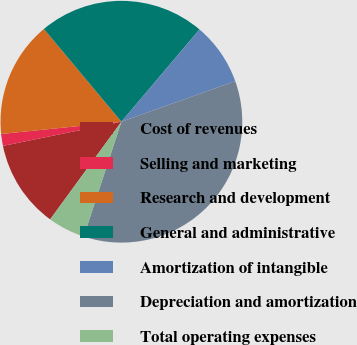Convert chart to OTSL. <chart><loc_0><loc_0><loc_500><loc_500><pie_chart><fcel>Cost of revenues<fcel>Selling and marketing<fcel>Research and development<fcel>General and administrative<fcel>Amortization of intangible<fcel>Depreciation and amortization<fcel>Total operating expenses<nl><fcel>11.76%<fcel>1.59%<fcel>15.54%<fcel>22.25%<fcel>8.37%<fcel>35.5%<fcel>4.98%<nl></chart> 